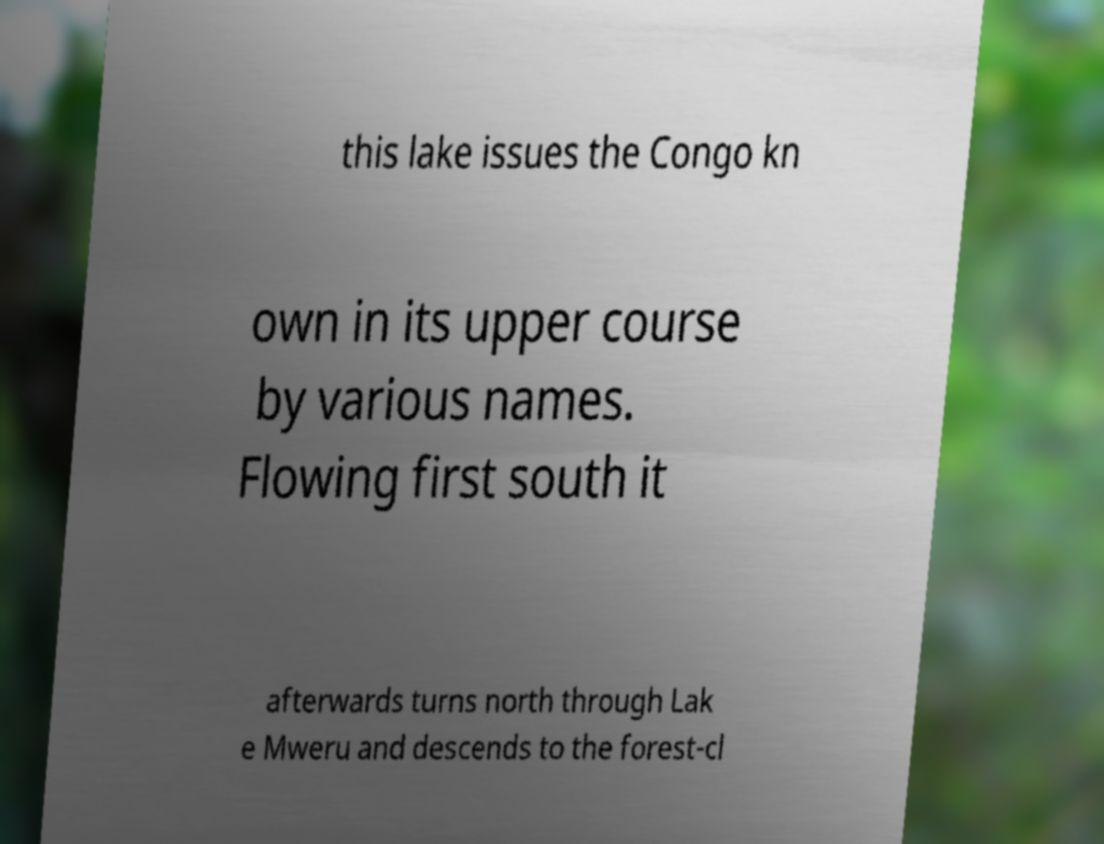What messages or text are displayed in this image? I need them in a readable, typed format. this lake issues the Congo kn own in its upper course by various names. Flowing first south it afterwards turns north through Lak e Mweru and descends to the forest-cl 